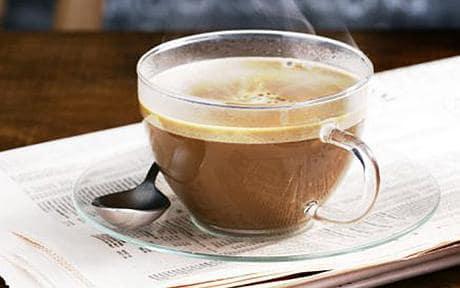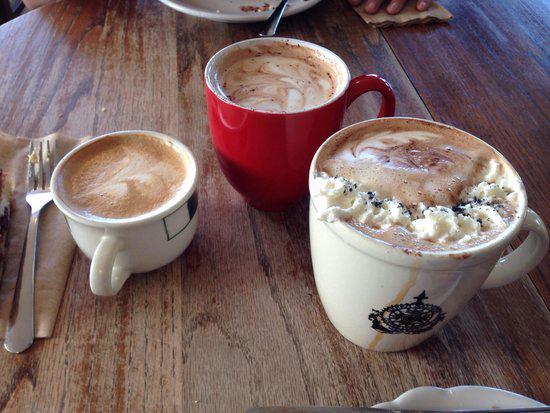The first image is the image on the left, the second image is the image on the right. Analyze the images presented: Is the assertion "Tea is being poured from a teapot into one of the white tea cups." valid? Answer yes or no. No. The first image is the image on the left, the second image is the image on the right. Evaluate the accuracy of this statement regarding the images: "tea is being poured from a spout". Is it true? Answer yes or no. No. 